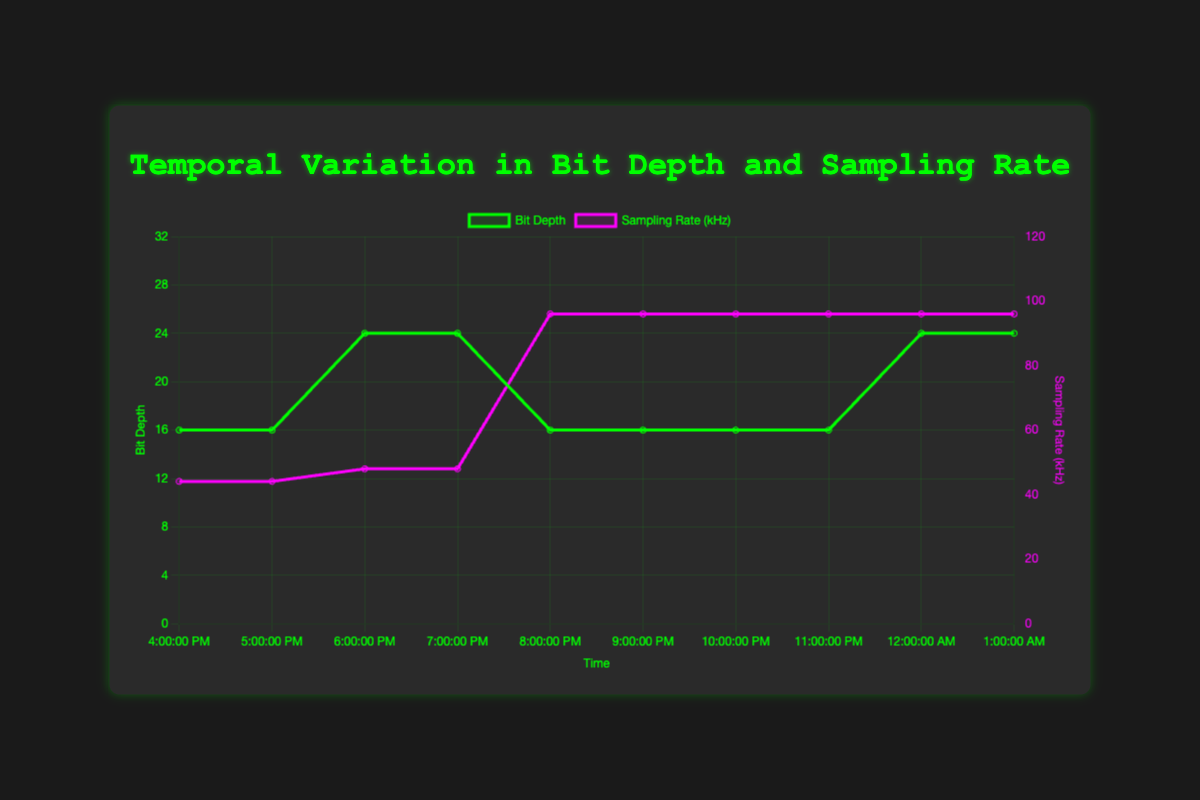What is the bit depth at 2 AM? The bit depth can be directly read from the bit depth curve on the plot at the timestamp corresponding to 2 AM. The marked bit depth value is 24 bits.
Answer: 24 At what timestamps did the bit depth change to 24? To answer this, identify the timestamps on the bit depth curve where the value changes from something else to 24. The timestamps are 2 AM, 3 AM, 8 AM, and 9 AM.
Answer: 2 AM, 3 AM, 8 AM, 9 AM Which source has the highest sampling rate? Compare the sampling rate curves and check the sources at the timestamps where the maximum value is reached. The highest sampling rate shown is 96 kHz by "Studio Reel 1," "Radio Broadcast 1," and "Master Tape 1."
Answer: Studio Reel 1, Radio Broadcast 1, Master Tape 1 What is the average bit depth for "Cassette_Tape_1"? Find bit depth values corresponding to "Cassette_Tape_1", which are at 2 AM and 3 AM (both are 24). Averaging these depths: (24 + 24)/2 = 24.
Answer: 24 Compare the durations for "Vinyl_Record_1" and "Radio_Broadcast_1." Which one has the longer total duration? Sum the durations for "Vinyl_Record_1" and "Radio_Broadcast_1" from the tooltip information. "Vinyl_Record_1" has 60 + 60 = 120 seconds, and "Radio_Broadcast_1" has 240 + 240 = 480 seconds. Comparing them, "Radio_Broadcast_1" has a longer total duration.
Answer: Radio_Broadcast_1 Does the sampling rate increase or decrease between 0 AM and 4 AM? Observe the sampling rate curve between 0 AM and 4 AM on the plot. It starts at 44.1 kHz at 0 AM and further fluctuating reaches 96 kHz by 4 AM. So, it increases overall.
Answer: Increase What is the bit depth at the longest duration session? Identify the session with the longest duration from the tooltip information. The 9 AM session has a duration of 300 seconds, and the bit depth is 24 bits.
Answer: 24 How many distinct sources are there in the dataset? Each tooltip reveals the source. By counting unique sources from all timestamps, there are five distinct sources: Vinyl_Record_1, Cassette_Tape_1, Studio_Reel_1, Radio_Broadcast_1, and Master_Tape_1.
Answer: 5 When is the first occurrence of a 96 kHz sampling rate? Look at the timestamp where the sampling rate curve first hits 96 kHz. This occurs at 4 AM.
Answer: 4 AM 